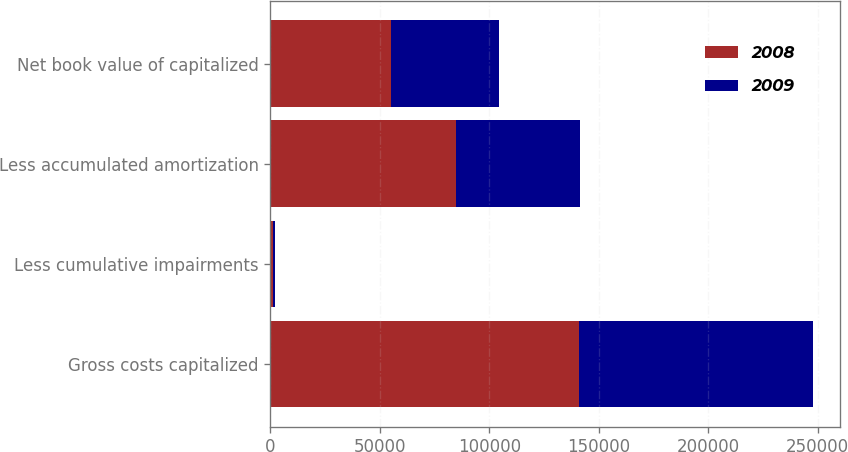Convert chart. <chart><loc_0><loc_0><loc_500><loc_500><stacked_bar_chart><ecel><fcel>Gross costs capitalized<fcel>Less cumulative impairments<fcel>Less accumulated amortization<fcel>Net book value of capitalized<nl><fcel>2008<fcel>140741<fcel>1156<fcel>84653<fcel>54932<nl><fcel>2009<fcel>107125<fcel>1050<fcel>56778<fcel>49297<nl></chart> 